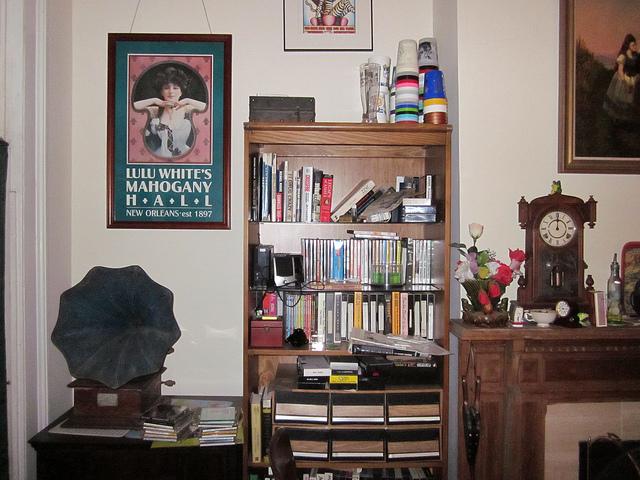What is on top of the bookcase?
Answer briefly. Cups. What time is it?
Keep it brief. 12:00. What color is the wall?
Give a very brief answer. White. 